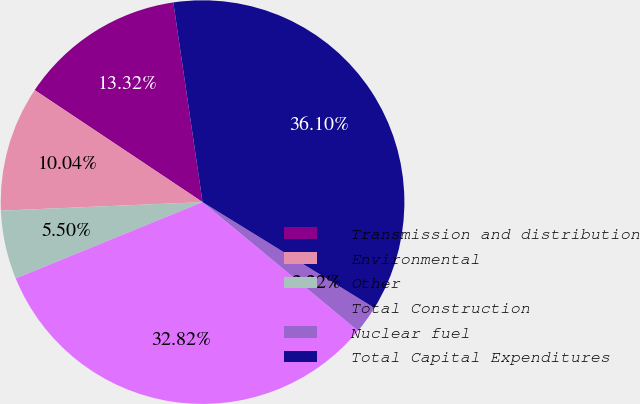Convert chart to OTSL. <chart><loc_0><loc_0><loc_500><loc_500><pie_chart><fcel>Transmission and distribution<fcel>Environmental<fcel>Other<fcel>Total Construction<fcel>Nuclear fuel<fcel>Total Capital Expenditures<nl><fcel>13.32%<fcel>10.04%<fcel>5.5%<fcel>32.82%<fcel>2.22%<fcel>36.1%<nl></chart> 